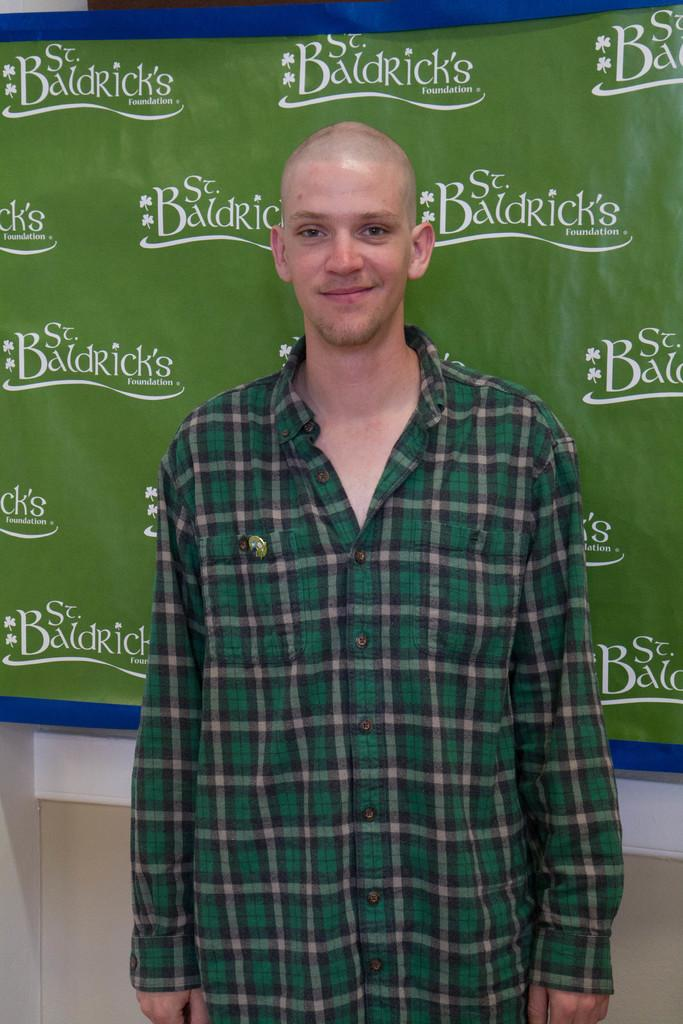Who is present in the image? There is a man in the image. What is the man's facial expression? The man is smiling. What can be seen in the background of the image? There is a banner and a wall in the background of the image. What is written on the banner? There is writing on the banner. How many horses are visible in the image? There are no horses present in the image. What type of toe is the man using to hold the banner? The man is not holding the banner with his toe, and there is no indication of any toes in the image. 